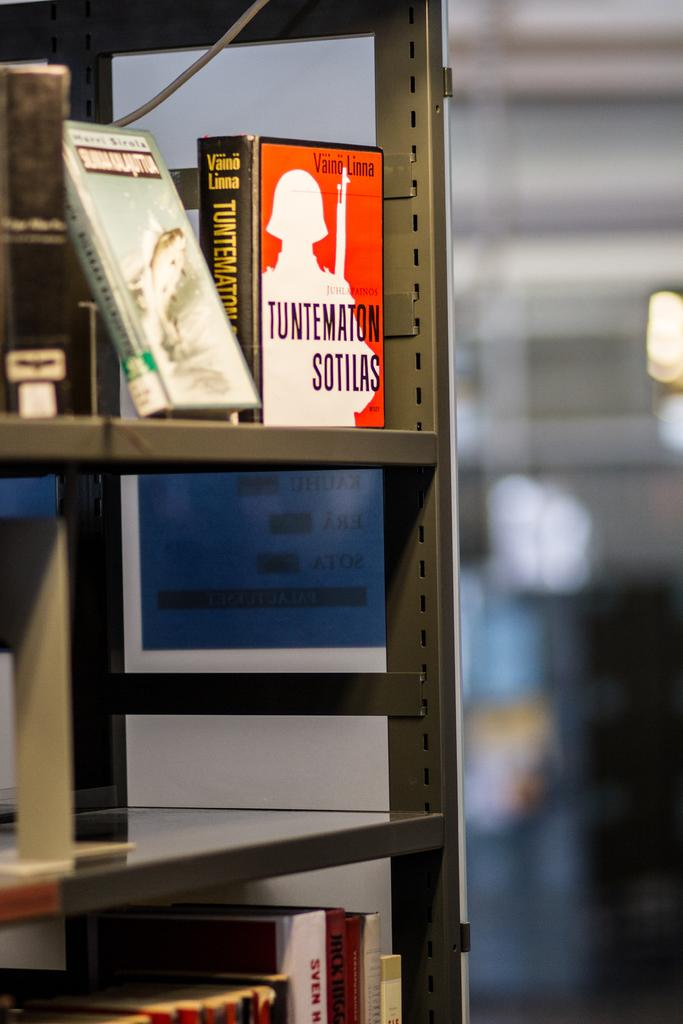Where was the image taken? The image was taken indoors. Can you describe the background of the image? The background of the image is slightly blurred. What can be seen on the left side of the image? There is a rack with shelves on the left side of the image. What items are on the shelves? There are a few books on the shelves. How many branches can be seen hanging from the ceiling in the image? There are no branches hanging from the ceiling in the image. Are there any bikes visible in the image? There are no bikes present in the image. 